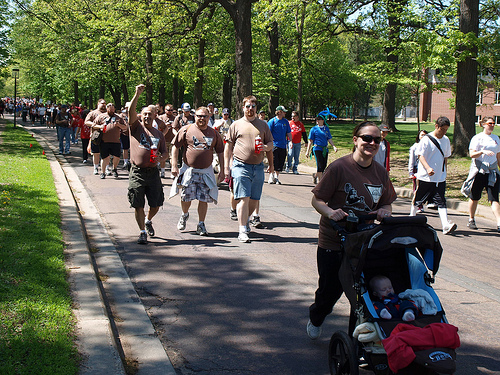<image>
Is the man to the left of the man? Yes. From this viewpoint, the man is positioned to the left side relative to the man. 